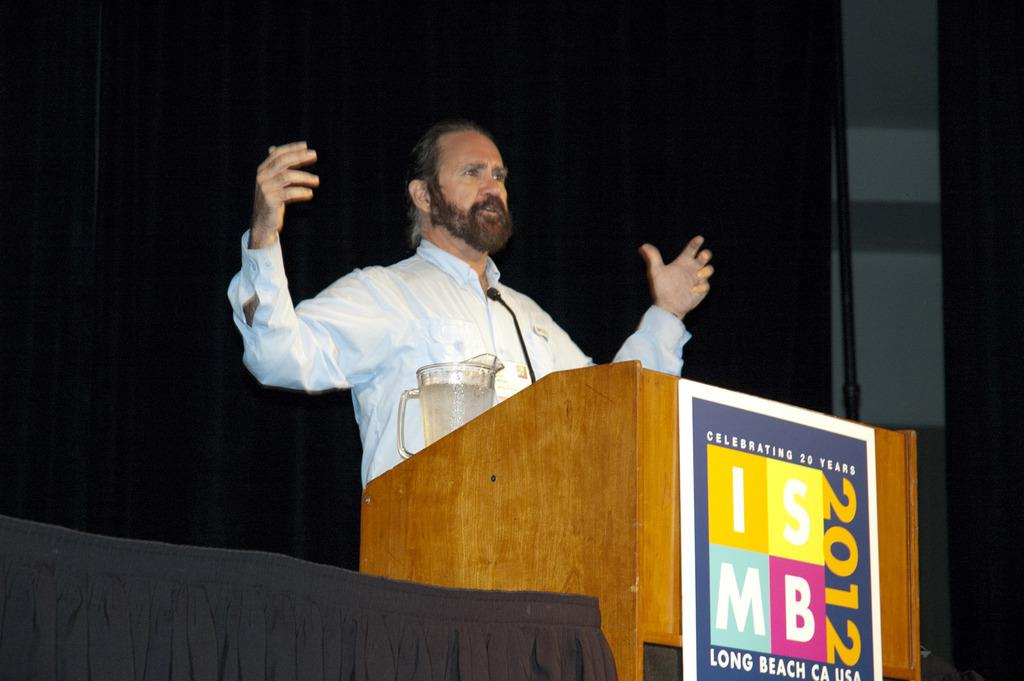<image>
Render a clear and concise summary of the photo. A man speaks from a podium with the year 2012 on it. 